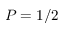<formula> <loc_0><loc_0><loc_500><loc_500>P = 1 / 2</formula> 